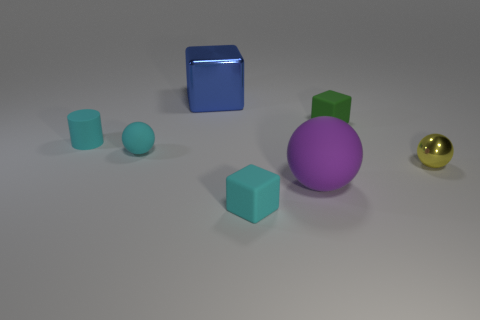Do the cyan cylinder and the green object have the same size?
Your response must be concise. Yes. What is the size of the block that is behind the rubber block behind the small cyan cube?
Your answer should be very brief. Large. How many objects are both in front of the small metallic ball and behind the green block?
Provide a short and direct response. 0. There is a cube on the right side of the matte block in front of the small matte cylinder; are there any metal balls that are to the right of it?
Offer a very short reply. Yes. There is a metallic thing that is the same size as the cyan sphere; what is its shape?
Your response must be concise. Sphere. Are there any spheres of the same color as the cylinder?
Offer a terse response. Yes. Is the big blue metallic thing the same shape as the small green object?
Your response must be concise. Yes. What number of large things are either matte objects or metallic objects?
Give a very brief answer. 2. The large object that is the same material as the cyan ball is what color?
Provide a succinct answer. Purple. What number of big blue blocks are made of the same material as the cylinder?
Give a very brief answer. 0. 